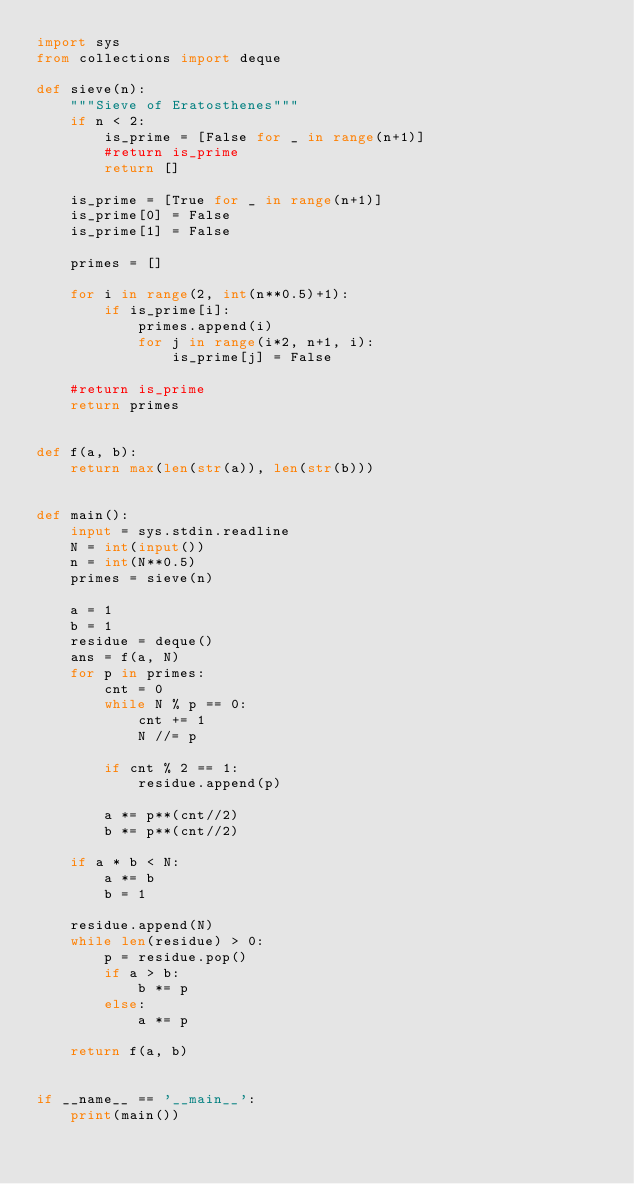<code> <loc_0><loc_0><loc_500><loc_500><_Python_>import sys
from collections import deque

def sieve(n):
    """Sieve of Eratosthenes"""
    if n < 2:
        is_prime = [False for _ in range(n+1)]
        #return is_prime
        return []

    is_prime = [True for _ in range(n+1)]
    is_prime[0] = False
    is_prime[1] = False

    primes = []

    for i in range(2, int(n**0.5)+1):
        if is_prime[i]:
            primes.append(i)
            for j in range(i*2, n+1, i):
                is_prime[j] = False

    #return is_prime
    return primes


def f(a, b):
    return max(len(str(a)), len(str(b)))


def main():
    input = sys.stdin.readline
    N = int(input())
    n = int(N**0.5)
    primes = sieve(n)

    a = 1
    b = 1
    residue = deque()
    ans = f(a, N)
    for p in primes:
        cnt = 0
        while N % p == 0:
            cnt += 1
            N //= p

        if cnt % 2 == 1:
            residue.append(p)

        a *= p**(cnt//2)
        b *= p**(cnt//2)

    if a * b < N:
        a *= b
        b = 1

    residue.append(N)
    while len(residue) > 0:
        p = residue.pop()
        if a > b:
            b *= p
        else:
            a *= p

    return f(a, b)


if __name__ == '__main__':
    print(main())
</code> 